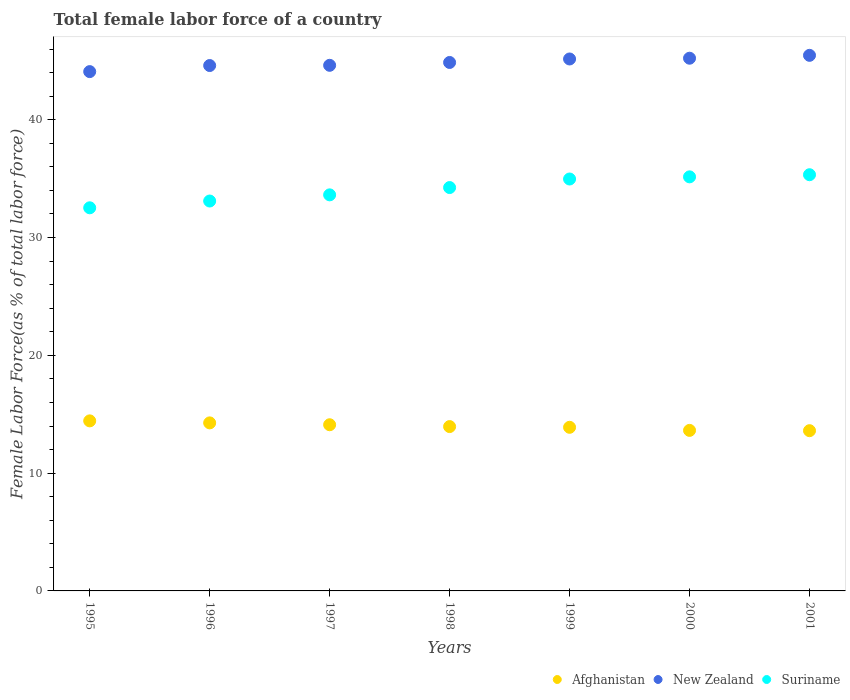How many different coloured dotlines are there?
Your answer should be compact. 3. Is the number of dotlines equal to the number of legend labels?
Your answer should be very brief. Yes. What is the percentage of female labor force in New Zealand in 1998?
Offer a very short reply. 44.86. Across all years, what is the maximum percentage of female labor force in Suriname?
Keep it short and to the point. 35.33. Across all years, what is the minimum percentage of female labor force in New Zealand?
Your answer should be very brief. 44.09. In which year was the percentage of female labor force in Suriname maximum?
Your response must be concise. 2001. What is the total percentage of female labor force in Afghanistan in the graph?
Provide a succinct answer. 97.88. What is the difference between the percentage of female labor force in Suriname in 1996 and that in 1999?
Make the answer very short. -1.87. What is the difference between the percentage of female labor force in Suriname in 1998 and the percentage of female labor force in New Zealand in 1999?
Your answer should be compact. -10.92. What is the average percentage of female labor force in Afghanistan per year?
Your answer should be very brief. 13.98. In the year 1997, what is the difference between the percentage of female labor force in New Zealand and percentage of female labor force in Afghanistan?
Offer a very short reply. 30.51. In how many years, is the percentage of female labor force in Afghanistan greater than 8 %?
Make the answer very short. 7. What is the ratio of the percentage of female labor force in New Zealand in 1995 to that in 2001?
Make the answer very short. 0.97. Is the percentage of female labor force in New Zealand in 1995 less than that in 1999?
Your answer should be very brief. Yes. What is the difference between the highest and the second highest percentage of female labor force in New Zealand?
Your response must be concise. 0.24. What is the difference between the highest and the lowest percentage of female labor force in New Zealand?
Offer a terse response. 1.38. Does the percentage of female labor force in Afghanistan monotonically increase over the years?
Offer a very short reply. No. Is the percentage of female labor force in Afghanistan strictly greater than the percentage of female labor force in New Zealand over the years?
Ensure brevity in your answer.  No. Is the percentage of female labor force in Afghanistan strictly less than the percentage of female labor force in New Zealand over the years?
Offer a terse response. Yes. What is the title of the graph?
Ensure brevity in your answer.  Total female labor force of a country. Does "Botswana" appear as one of the legend labels in the graph?
Provide a succinct answer. No. What is the label or title of the Y-axis?
Offer a very short reply. Female Labor Force(as % of total labor force). What is the Female Labor Force(as % of total labor force) in Afghanistan in 1995?
Provide a short and direct response. 14.44. What is the Female Labor Force(as % of total labor force) in New Zealand in 1995?
Offer a very short reply. 44.09. What is the Female Labor Force(as % of total labor force) of Suriname in 1995?
Your response must be concise. 32.53. What is the Female Labor Force(as % of total labor force) of Afghanistan in 1996?
Offer a terse response. 14.27. What is the Female Labor Force(as % of total labor force) of New Zealand in 1996?
Provide a short and direct response. 44.6. What is the Female Labor Force(as % of total labor force) in Suriname in 1996?
Provide a succinct answer. 33.1. What is the Female Labor Force(as % of total labor force) in Afghanistan in 1997?
Offer a very short reply. 14.11. What is the Female Labor Force(as % of total labor force) of New Zealand in 1997?
Keep it short and to the point. 44.62. What is the Female Labor Force(as % of total labor force) in Suriname in 1997?
Offer a terse response. 33.62. What is the Female Labor Force(as % of total labor force) of Afghanistan in 1998?
Provide a short and direct response. 13.95. What is the Female Labor Force(as % of total labor force) in New Zealand in 1998?
Your response must be concise. 44.86. What is the Female Labor Force(as % of total labor force) in Suriname in 1998?
Provide a short and direct response. 34.24. What is the Female Labor Force(as % of total labor force) of Afghanistan in 1999?
Give a very brief answer. 13.89. What is the Female Labor Force(as % of total labor force) of New Zealand in 1999?
Provide a succinct answer. 45.16. What is the Female Labor Force(as % of total labor force) of Suriname in 1999?
Your answer should be very brief. 34.97. What is the Female Labor Force(as % of total labor force) of Afghanistan in 2000?
Provide a succinct answer. 13.63. What is the Female Labor Force(as % of total labor force) in New Zealand in 2000?
Offer a terse response. 45.22. What is the Female Labor Force(as % of total labor force) of Suriname in 2000?
Ensure brevity in your answer.  35.15. What is the Female Labor Force(as % of total labor force) of Afghanistan in 2001?
Make the answer very short. 13.6. What is the Female Labor Force(as % of total labor force) in New Zealand in 2001?
Your response must be concise. 45.47. What is the Female Labor Force(as % of total labor force) of Suriname in 2001?
Make the answer very short. 35.33. Across all years, what is the maximum Female Labor Force(as % of total labor force) in Afghanistan?
Ensure brevity in your answer.  14.44. Across all years, what is the maximum Female Labor Force(as % of total labor force) of New Zealand?
Provide a short and direct response. 45.47. Across all years, what is the maximum Female Labor Force(as % of total labor force) in Suriname?
Provide a succinct answer. 35.33. Across all years, what is the minimum Female Labor Force(as % of total labor force) of Afghanistan?
Your answer should be very brief. 13.6. Across all years, what is the minimum Female Labor Force(as % of total labor force) of New Zealand?
Offer a terse response. 44.09. Across all years, what is the minimum Female Labor Force(as % of total labor force) in Suriname?
Keep it short and to the point. 32.53. What is the total Female Labor Force(as % of total labor force) in Afghanistan in the graph?
Provide a succinct answer. 97.88. What is the total Female Labor Force(as % of total labor force) in New Zealand in the graph?
Give a very brief answer. 314.02. What is the total Female Labor Force(as % of total labor force) of Suriname in the graph?
Provide a short and direct response. 238.95. What is the difference between the Female Labor Force(as % of total labor force) in Afghanistan in 1995 and that in 1996?
Make the answer very short. 0.17. What is the difference between the Female Labor Force(as % of total labor force) in New Zealand in 1995 and that in 1996?
Offer a very short reply. -0.52. What is the difference between the Female Labor Force(as % of total labor force) of Suriname in 1995 and that in 1996?
Your answer should be compact. -0.58. What is the difference between the Female Labor Force(as % of total labor force) in Afghanistan in 1995 and that in 1997?
Your answer should be very brief. 0.33. What is the difference between the Female Labor Force(as % of total labor force) of New Zealand in 1995 and that in 1997?
Your response must be concise. -0.53. What is the difference between the Female Labor Force(as % of total labor force) in Suriname in 1995 and that in 1997?
Provide a succinct answer. -1.1. What is the difference between the Female Labor Force(as % of total labor force) of Afghanistan in 1995 and that in 1998?
Offer a very short reply. 0.48. What is the difference between the Female Labor Force(as % of total labor force) of New Zealand in 1995 and that in 1998?
Offer a very short reply. -0.78. What is the difference between the Female Labor Force(as % of total labor force) in Suriname in 1995 and that in 1998?
Ensure brevity in your answer.  -1.72. What is the difference between the Female Labor Force(as % of total labor force) of Afghanistan in 1995 and that in 1999?
Your answer should be very brief. 0.55. What is the difference between the Female Labor Force(as % of total labor force) of New Zealand in 1995 and that in 1999?
Your answer should be very brief. -1.07. What is the difference between the Female Labor Force(as % of total labor force) in Suriname in 1995 and that in 1999?
Provide a succinct answer. -2.44. What is the difference between the Female Labor Force(as % of total labor force) of Afghanistan in 1995 and that in 2000?
Your answer should be very brief. 0.81. What is the difference between the Female Labor Force(as % of total labor force) of New Zealand in 1995 and that in 2000?
Your response must be concise. -1.14. What is the difference between the Female Labor Force(as % of total labor force) of Suriname in 1995 and that in 2000?
Provide a succinct answer. -2.63. What is the difference between the Female Labor Force(as % of total labor force) of Afghanistan in 1995 and that in 2001?
Offer a terse response. 0.83. What is the difference between the Female Labor Force(as % of total labor force) in New Zealand in 1995 and that in 2001?
Offer a very short reply. -1.38. What is the difference between the Female Labor Force(as % of total labor force) in Suriname in 1995 and that in 2001?
Offer a very short reply. -2.81. What is the difference between the Female Labor Force(as % of total labor force) of Afghanistan in 1996 and that in 1997?
Offer a terse response. 0.16. What is the difference between the Female Labor Force(as % of total labor force) in New Zealand in 1996 and that in 1997?
Provide a succinct answer. -0.02. What is the difference between the Female Labor Force(as % of total labor force) in Suriname in 1996 and that in 1997?
Give a very brief answer. -0.52. What is the difference between the Female Labor Force(as % of total labor force) of Afghanistan in 1996 and that in 1998?
Provide a short and direct response. 0.31. What is the difference between the Female Labor Force(as % of total labor force) of New Zealand in 1996 and that in 1998?
Your response must be concise. -0.26. What is the difference between the Female Labor Force(as % of total labor force) in Suriname in 1996 and that in 1998?
Your response must be concise. -1.14. What is the difference between the Female Labor Force(as % of total labor force) of Afghanistan in 1996 and that in 1999?
Provide a short and direct response. 0.38. What is the difference between the Female Labor Force(as % of total labor force) in New Zealand in 1996 and that in 1999?
Provide a short and direct response. -0.56. What is the difference between the Female Labor Force(as % of total labor force) of Suriname in 1996 and that in 1999?
Your answer should be compact. -1.87. What is the difference between the Female Labor Force(as % of total labor force) in Afghanistan in 1996 and that in 2000?
Provide a short and direct response. 0.64. What is the difference between the Female Labor Force(as % of total labor force) of New Zealand in 1996 and that in 2000?
Your answer should be compact. -0.62. What is the difference between the Female Labor Force(as % of total labor force) of Suriname in 1996 and that in 2000?
Keep it short and to the point. -2.05. What is the difference between the Female Labor Force(as % of total labor force) of Afghanistan in 1996 and that in 2001?
Give a very brief answer. 0.66. What is the difference between the Female Labor Force(as % of total labor force) in New Zealand in 1996 and that in 2001?
Your answer should be compact. -0.87. What is the difference between the Female Labor Force(as % of total labor force) in Suriname in 1996 and that in 2001?
Ensure brevity in your answer.  -2.23. What is the difference between the Female Labor Force(as % of total labor force) of Afghanistan in 1997 and that in 1998?
Offer a very short reply. 0.16. What is the difference between the Female Labor Force(as % of total labor force) of New Zealand in 1997 and that in 1998?
Offer a terse response. -0.24. What is the difference between the Female Labor Force(as % of total labor force) in Suriname in 1997 and that in 1998?
Your answer should be compact. -0.62. What is the difference between the Female Labor Force(as % of total labor force) in Afghanistan in 1997 and that in 1999?
Keep it short and to the point. 0.22. What is the difference between the Female Labor Force(as % of total labor force) in New Zealand in 1997 and that in 1999?
Ensure brevity in your answer.  -0.54. What is the difference between the Female Labor Force(as % of total labor force) in Suriname in 1997 and that in 1999?
Provide a succinct answer. -1.35. What is the difference between the Female Labor Force(as % of total labor force) in Afghanistan in 1997 and that in 2000?
Keep it short and to the point. 0.48. What is the difference between the Female Labor Force(as % of total labor force) in New Zealand in 1997 and that in 2000?
Offer a very short reply. -0.6. What is the difference between the Female Labor Force(as % of total labor force) in Suriname in 1997 and that in 2000?
Offer a very short reply. -1.53. What is the difference between the Female Labor Force(as % of total labor force) of Afghanistan in 1997 and that in 2001?
Keep it short and to the point. 0.51. What is the difference between the Female Labor Force(as % of total labor force) in New Zealand in 1997 and that in 2001?
Keep it short and to the point. -0.85. What is the difference between the Female Labor Force(as % of total labor force) of Suriname in 1997 and that in 2001?
Make the answer very short. -1.71. What is the difference between the Female Labor Force(as % of total labor force) in Afghanistan in 1998 and that in 1999?
Provide a short and direct response. 0.06. What is the difference between the Female Labor Force(as % of total labor force) in New Zealand in 1998 and that in 1999?
Make the answer very short. -0.3. What is the difference between the Female Labor Force(as % of total labor force) of Suriname in 1998 and that in 1999?
Provide a succinct answer. -0.73. What is the difference between the Female Labor Force(as % of total labor force) of Afghanistan in 1998 and that in 2000?
Offer a terse response. 0.32. What is the difference between the Female Labor Force(as % of total labor force) in New Zealand in 1998 and that in 2000?
Make the answer very short. -0.36. What is the difference between the Female Labor Force(as % of total labor force) in Suriname in 1998 and that in 2000?
Your answer should be very brief. -0.91. What is the difference between the Female Labor Force(as % of total labor force) in Afghanistan in 1998 and that in 2001?
Keep it short and to the point. 0.35. What is the difference between the Female Labor Force(as % of total labor force) in New Zealand in 1998 and that in 2001?
Offer a very short reply. -0.6. What is the difference between the Female Labor Force(as % of total labor force) of Suriname in 1998 and that in 2001?
Offer a terse response. -1.09. What is the difference between the Female Labor Force(as % of total labor force) of Afghanistan in 1999 and that in 2000?
Give a very brief answer. 0.26. What is the difference between the Female Labor Force(as % of total labor force) in New Zealand in 1999 and that in 2000?
Provide a short and direct response. -0.06. What is the difference between the Female Labor Force(as % of total labor force) of Suriname in 1999 and that in 2000?
Your response must be concise. -0.18. What is the difference between the Female Labor Force(as % of total labor force) in Afghanistan in 1999 and that in 2001?
Make the answer very short. 0.29. What is the difference between the Female Labor Force(as % of total labor force) in New Zealand in 1999 and that in 2001?
Offer a very short reply. -0.31. What is the difference between the Female Labor Force(as % of total labor force) in Suriname in 1999 and that in 2001?
Ensure brevity in your answer.  -0.36. What is the difference between the Female Labor Force(as % of total labor force) of Afghanistan in 2000 and that in 2001?
Your answer should be compact. 0.03. What is the difference between the Female Labor Force(as % of total labor force) in New Zealand in 2000 and that in 2001?
Your answer should be very brief. -0.24. What is the difference between the Female Labor Force(as % of total labor force) of Suriname in 2000 and that in 2001?
Make the answer very short. -0.18. What is the difference between the Female Labor Force(as % of total labor force) in Afghanistan in 1995 and the Female Labor Force(as % of total labor force) in New Zealand in 1996?
Make the answer very short. -30.17. What is the difference between the Female Labor Force(as % of total labor force) in Afghanistan in 1995 and the Female Labor Force(as % of total labor force) in Suriname in 1996?
Provide a short and direct response. -18.66. What is the difference between the Female Labor Force(as % of total labor force) in New Zealand in 1995 and the Female Labor Force(as % of total labor force) in Suriname in 1996?
Provide a succinct answer. 10.99. What is the difference between the Female Labor Force(as % of total labor force) in Afghanistan in 1995 and the Female Labor Force(as % of total labor force) in New Zealand in 1997?
Offer a very short reply. -30.18. What is the difference between the Female Labor Force(as % of total labor force) in Afghanistan in 1995 and the Female Labor Force(as % of total labor force) in Suriname in 1997?
Provide a succinct answer. -19.19. What is the difference between the Female Labor Force(as % of total labor force) in New Zealand in 1995 and the Female Labor Force(as % of total labor force) in Suriname in 1997?
Keep it short and to the point. 10.46. What is the difference between the Female Labor Force(as % of total labor force) of Afghanistan in 1995 and the Female Labor Force(as % of total labor force) of New Zealand in 1998?
Offer a terse response. -30.43. What is the difference between the Female Labor Force(as % of total labor force) in Afghanistan in 1995 and the Female Labor Force(as % of total labor force) in Suriname in 1998?
Keep it short and to the point. -19.81. What is the difference between the Female Labor Force(as % of total labor force) in New Zealand in 1995 and the Female Labor Force(as % of total labor force) in Suriname in 1998?
Your answer should be compact. 9.84. What is the difference between the Female Labor Force(as % of total labor force) in Afghanistan in 1995 and the Female Labor Force(as % of total labor force) in New Zealand in 1999?
Ensure brevity in your answer.  -30.72. What is the difference between the Female Labor Force(as % of total labor force) in Afghanistan in 1995 and the Female Labor Force(as % of total labor force) in Suriname in 1999?
Your answer should be very brief. -20.53. What is the difference between the Female Labor Force(as % of total labor force) in New Zealand in 1995 and the Female Labor Force(as % of total labor force) in Suriname in 1999?
Ensure brevity in your answer.  9.12. What is the difference between the Female Labor Force(as % of total labor force) of Afghanistan in 1995 and the Female Labor Force(as % of total labor force) of New Zealand in 2000?
Offer a very short reply. -30.79. What is the difference between the Female Labor Force(as % of total labor force) of Afghanistan in 1995 and the Female Labor Force(as % of total labor force) of Suriname in 2000?
Ensure brevity in your answer.  -20.72. What is the difference between the Female Labor Force(as % of total labor force) of New Zealand in 1995 and the Female Labor Force(as % of total labor force) of Suriname in 2000?
Give a very brief answer. 8.93. What is the difference between the Female Labor Force(as % of total labor force) in Afghanistan in 1995 and the Female Labor Force(as % of total labor force) in New Zealand in 2001?
Ensure brevity in your answer.  -31.03. What is the difference between the Female Labor Force(as % of total labor force) of Afghanistan in 1995 and the Female Labor Force(as % of total labor force) of Suriname in 2001?
Provide a short and direct response. -20.9. What is the difference between the Female Labor Force(as % of total labor force) of New Zealand in 1995 and the Female Labor Force(as % of total labor force) of Suriname in 2001?
Provide a short and direct response. 8.75. What is the difference between the Female Labor Force(as % of total labor force) in Afghanistan in 1996 and the Female Labor Force(as % of total labor force) in New Zealand in 1997?
Offer a terse response. -30.36. What is the difference between the Female Labor Force(as % of total labor force) of Afghanistan in 1996 and the Female Labor Force(as % of total labor force) of Suriname in 1997?
Give a very brief answer. -19.36. What is the difference between the Female Labor Force(as % of total labor force) in New Zealand in 1996 and the Female Labor Force(as % of total labor force) in Suriname in 1997?
Provide a succinct answer. 10.98. What is the difference between the Female Labor Force(as % of total labor force) of Afghanistan in 1996 and the Female Labor Force(as % of total labor force) of New Zealand in 1998?
Make the answer very short. -30.6. What is the difference between the Female Labor Force(as % of total labor force) of Afghanistan in 1996 and the Female Labor Force(as % of total labor force) of Suriname in 1998?
Keep it short and to the point. -19.98. What is the difference between the Female Labor Force(as % of total labor force) of New Zealand in 1996 and the Female Labor Force(as % of total labor force) of Suriname in 1998?
Provide a short and direct response. 10.36. What is the difference between the Female Labor Force(as % of total labor force) in Afghanistan in 1996 and the Female Labor Force(as % of total labor force) in New Zealand in 1999?
Keep it short and to the point. -30.89. What is the difference between the Female Labor Force(as % of total labor force) in Afghanistan in 1996 and the Female Labor Force(as % of total labor force) in Suriname in 1999?
Provide a short and direct response. -20.7. What is the difference between the Female Labor Force(as % of total labor force) in New Zealand in 1996 and the Female Labor Force(as % of total labor force) in Suriname in 1999?
Keep it short and to the point. 9.63. What is the difference between the Female Labor Force(as % of total labor force) in Afghanistan in 1996 and the Female Labor Force(as % of total labor force) in New Zealand in 2000?
Give a very brief answer. -30.96. What is the difference between the Female Labor Force(as % of total labor force) in Afghanistan in 1996 and the Female Labor Force(as % of total labor force) in Suriname in 2000?
Keep it short and to the point. -20.89. What is the difference between the Female Labor Force(as % of total labor force) of New Zealand in 1996 and the Female Labor Force(as % of total labor force) of Suriname in 2000?
Your response must be concise. 9.45. What is the difference between the Female Labor Force(as % of total labor force) of Afghanistan in 1996 and the Female Labor Force(as % of total labor force) of New Zealand in 2001?
Ensure brevity in your answer.  -31.2. What is the difference between the Female Labor Force(as % of total labor force) in Afghanistan in 1996 and the Female Labor Force(as % of total labor force) in Suriname in 2001?
Your answer should be compact. -21.07. What is the difference between the Female Labor Force(as % of total labor force) of New Zealand in 1996 and the Female Labor Force(as % of total labor force) of Suriname in 2001?
Your answer should be compact. 9.27. What is the difference between the Female Labor Force(as % of total labor force) in Afghanistan in 1997 and the Female Labor Force(as % of total labor force) in New Zealand in 1998?
Your answer should be very brief. -30.76. What is the difference between the Female Labor Force(as % of total labor force) of Afghanistan in 1997 and the Female Labor Force(as % of total labor force) of Suriname in 1998?
Provide a short and direct response. -20.14. What is the difference between the Female Labor Force(as % of total labor force) of New Zealand in 1997 and the Female Labor Force(as % of total labor force) of Suriname in 1998?
Offer a terse response. 10.38. What is the difference between the Female Labor Force(as % of total labor force) in Afghanistan in 1997 and the Female Labor Force(as % of total labor force) in New Zealand in 1999?
Ensure brevity in your answer.  -31.05. What is the difference between the Female Labor Force(as % of total labor force) in Afghanistan in 1997 and the Female Labor Force(as % of total labor force) in Suriname in 1999?
Offer a very short reply. -20.86. What is the difference between the Female Labor Force(as % of total labor force) in New Zealand in 1997 and the Female Labor Force(as % of total labor force) in Suriname in 1999?
Provide a succinct answer. 9.65. What is the difference between the Female Labor Force(as % of total labor force) in Afghanistan in 1997 and the Female Labor Force(as % of total labor force) in New Zealand in 2000?
Give a very brief answer. -31.12. What is the difference between the Female Labor Force(as % of total labor force) of Afghanistan in 1997 and the Female Labor Force(as % of total labor force) of Suriname in 2000?
Your answer should be compact. -21.04. What is the difference between the Female Labor Force(as % of total labor force) of New Zealand in 1997 and the Female Labor Force(as % of total labor force) of Suriname in 2000?
Give a very brief answer. 9.47. What is the difference between the Female Labor Force(as % of total labor force) in Afghanistan in 1997 and the Female Labor Force(as % of total labor force) in New Zealand in 2001?
Offer a terse response. -31.36. What is the difference between the Female Labor Force(as % of total labor force) of Afghanistan in 1997 and the Female Labor Force(as % of total labor force) of Suriname in 2001?
Your answer should be compact. -21.23. What is the difference between the Female Labor Force(as % of total labor force) in New Zealand in 1997 and the Female Labor Force(as % of total labor force) in Suriname in 2001?
Your response must be concise. 9.29. What is the difference between the Female Labor Force(as % of total labor force) in Afghanistan in 1998 and the Female Labor Force(as % of total labor force) in New Zealand in 1999?
Ensure brevity in your answer.  -31.21. What is the difference between the Female Labor Force(as % of total labor force) of Afghanistan in 1998 and the Female Labor Force(as % of total labor force) of Suriname in 1999?
Provide a succinct answer. -21.02. What is the difference between the Female Labor Force(as % of total labor force) in New Zealand in 1998 and the Female Labor Force(as % of total labor force) in Suriname in 1999?
Provide a short and direct response. 9.89. What is the difference between the Female Labor Force(as % of total labor force) in Afghanistan in 1998 and the Female Labor Force(as % of total labor force) in New Zealand in 2000?
Offer a terse response. -31.27. What is the difference between the Female Labor Force(as % of total labor force) of Afghanistan in 1998 and the Female Labor Force(as % of total labor force) of Suriname in 2000?
Give a very brief answer. -21.2. What is the difference between the Female Labor Force(as % of total labor force) of New Zealand in 1998 and the Female Labor Force(as % of total labor force) of Suriname in 2000?
Keep it short and to the point. 9.71. What is the difference between the Female Labor Force(as % of total labor force) in Afghanistan in 1998 and the Female Labor Force(as % of total labor force) in New Zealand in 2001?
Keep it short and to the point. -31.52. What is the difference between the Female Labor Force(as % of total labor force) in Afghanistan in 1998 and the Female Labor Force(as % of total labor force) in Suriname in 2001?
Offer a terse response. -21.38. What is the difference between the Female Labor Force(as % of total labor force) of New Zealand in 1998 and the Female Labor Force(as % of total labor force) of Suriname in 2001?
Ensure brevity in your answer.  9.53. What is the difference between the Female Labor Force(as % of total labor force) in Afghanistan in 1999 and the Female Labor Force(as % of total labor force) in New Zealand in 2000?
Your response must be concise. -31.33. What is the difference between the Female Labor Force(as % of total labor force) of Afghanistan in 1999 and the Female Labor Force(as % of total labor force) of Suriname in 2000?
Provide a short and direct response. -21.26. What is the difference between the Female Labor Force(as % of total labor force) of New Zealand in 1999 and the Female Labor Force(as % of total labor force) of Suriname in 2000?
Offer a terse response. 10.01. What is the difference between the Female Labor Force(as % of total labor force) of Afghanistan in 1999 and the Female Labor Force(as % of total labor force) of New Zealand in 2001?
Ensure brevity in your answer.  -31.58. What is the difference between the Female Labor Force(as % of total labor force) of Afghanistan in 1999 and the Female Labor Force(as % of total labor force) of Suriname in 2001?
Your answer should be compact. -21.44. What is the difference between the Female Labor Force(as % of total labor force) of New Zealand in 1999 and the Female Labor Force(as % of total labor force) of Suriname in 2001?
Give a very brief answer. 9.83. What is the difference between the Female Labor Force(as % of total labor force) in Afghanistan in 2000 and the Female Labor Force(as % of total labor force) in New Zealand in 2001?
Your answer should be very brief. -31.84. What is the difference between the Female Labor Force(as % of total labor force) in Afghanistan in 2000 and the Female Labor Force(as % of total labor force) in Suriname in 2001?
Ensure brevity in your answer.  -21.7. What is the difference between the Female Labor Force(as % of total labor force) of New Zealand in 2000 and the Female Labor Force(as % of total labor force) of Suriname in 2001?
Provide a short and direct response. 9.89. What is the average Female Labor Force(as % of total labor force) of Afghanistan per year?
Give a very brief answer. 13.98. What is the average Female Labor Force(as % of total labor force) in New Zealand per year?
Provide a succinct answer. 44.86. What is the average Female Labor Force(as % of total labor force) of Suriname per year?
Your response must be concise. 34.14. In the year 1995, what is the difference between the Female Labor Force(as % of total labor force) of Afghanistan and Female Labor Force(as % of total labor force) of New Zealand?
Keep it short and to the point. -29.65. In the year 1995, what is the difference between the Female Labor Force(as % of total labor force) in Afghanistan and Female Labor Force(as % of total labor force) in Suriname?
Provide a short and direct response. -18.09. In the year 1995, what is the difference between the Female Labor Force(as % of total labor force) of New Zealand and Female Labor Force(as % of total labor force) of Suriname?
Offer a very short reply. 11.56. In the year 1996, what is the difference between the Female Labor Force(as % of total labor force) of Afghanistan and Female Labor Force(as % of total labor force) of New Zealand?
Keep it short and to the point. -30.34. In the year 1996, what is the difference between the Female Labor Force(as % of total labor force) in Afghanistan and Female Labor Force(as % of total labor force) in Suriname?
Offer a terse response. -18.83. In the year 1996, what is the difference between the Female Labor Force(as % of total labor force) in New Zealand and Female Labor Force(as % of total labor force) in Suriname?
Your response must be concise. 11.5. In the year 1997, what is the difference between the Female Labor Force(as % of total labor force) of Afghanistan and Female Labor Force(as % of total labor force) of New Zealand?
Your answer should be compact. -30.51. In the year 1997, what is the difference between the Female Labor Force(as % of total labor force) of Afghanistan and Female Labor Force(as % of total labor force) of Suriname?
Keep it short and to the point. -19.52. In the year 1997, what is the difference between the Female Labor Force(as % of total labor force) of New Zealand and Female Labor Force(as % of total labor force) of Suriname?
Give a very brief answer. 11. In the year 1998, what is the difference between the Female Labor Force(as % of total labor force) in Afghanistan and Female Labor Force(as % of total labor force) in New Zealand?
Offer a terse response. -30.91. In the year 1998, what is the difference between the Female Labor Force(as % of total labor force) in Afghanistan and Female Labor Force(as % of total labor force) in Suriname?
Offer a terse response. -20.29. In the year 1998, what is the difference between the Female Labor Force(as % of total labor force) of New Zealand and Female Labor Force(as % of total labor force) of Suriname?
Make the answer very short. 10.62. In the year 1999, what is the difference between the Female Labor Force(as % of total labor force) in Afghanistan and Female Labor Force(as % of total labor force) in New Zealand?
Offer a terse response. -31.27. In the year 1999, what is the difference between the Female Labor Force(as % of total labor force) in Afghanistan and Female Labor Force(as % of total labor force) in Suriname?
Provide a short and direct response. -21.08. In the year 1999, what is the difference between the Female Labor Force(as % of total labor force) in New Zealand and Female Labor Force(as % of total labor force) in Suriname?
Provide a short and direct response. 10.19. In the year 2000, what is the difference between the Female Labor Force(as % of total labor force) of Afghanistan and Female Labor Force(as % of total labor force) of New Zealand?
Your response must be concise. -31.6. In the year 2000, what is the difference between the Female Labor Force(as % of total labor force) of Afghanistan and Female Labor Force(as % of total labor force) of Suriname?
Give a very brief answer. -21.52. In the year 2000, what is the difference between the Female Labor Force(as % of total labor force) of New Zealand and Female Labor Force(as % of total labor force) of Suriname?
Your answer should be very brief. 10.07. In the year 2001, what is the difference between the Female Labor Force(as % of total labor force) of Afghanistan and Female Labor Force(as % of total labor force) of New Zealand?
Your answer should be very brief. -31.87. In the year 2001, what is the difference between the Female Labor Force(as % of total labor force) in Afghanistan and Female Labor Force(as % of total labor force) in Suriname?
Your answer should be very brief. -21.73. In the year 2001, what is the difference between the Female Labor Force(as % of total labor force) in New Zealand and Female Labor Force(as % of total labor force) in Suriname?
Offer a terse response. 10.13. What is the ratio of the Female Labor Force(as % of total labor force) in Afghanistan in 1995 to that in 1996?
Your answer should be very brief. 1.01. What is the ratio of the Female Labor Force(as % of total labor force) in New Zealand in 1995 to that in 1996?
Provide a succinct answer. 0.99. What is the ratio of the Female Labor Force(as % of total labor force) of Suriname in 1995 to that in 1996?
Provide a short and direct response. 0.98. What is the ratio of the Female Labor Force(as % of total labor force) of Afghanistan in 1995 to that in 1997?
Make the answer very short. 1.02. What is the ratio of the Female Labor Force(as % of total labor force) of Suriname in 1995 to that in 1997?
Your response must be concise. 0.97. What is the ratio of the Female Labor Force(as % of total labor force) of Afghanistan in 1995 to that in 1998?
Offer a very short reply. 1.03. What is the ratio of the Female Labor Force(as % of total labor force) of New Zealand in 1995 to that in 1998?
Keep it short and to the point. 0.98. What is the ratio of the Female Labor Force(as % of total labor force) in Suriname in 1995 to that in 1998?
Provide a short and direct response. 0.95. What is the ratio of the Female Labor Force(as % of total labor force) of Afghanistan in 1995 to that in 1999?
Give a very brief answer. 1.04. What is the ratio of the Female Labor Force(as % of total labor force) in New Zealand in 1995 to that in 1999?
Offer a very short reply. 0.98. What is the ratio of the Female Labor Force(as % of total labor force) of Suriname in 1995 to that in 1999?
Provide a succinct answer. 0.93. What is the ratio of the Female Labor Force(as % of total labor force) of Afghanistan in 1995 to that in 2000?
Offer a very short reply. 1.06. What is the ratio of the Female Labor Force(as % of total labor force) of New Zealand in 1995 to that in 2000?
Your answer should be compact. 0.97. What is the ratio of the Female Labor Force(as % of total labor force) of Suriname in 1995 to that in 2000?
Provide a short and direct response. 0.93. What is the ratio of the Female Labor Force(as % of total labor force) in Afghanistan in 1995 to that in 2001?
Provide a short and direct response. 1.06. What is the ratio of the Female Labor Force(as % of total labor force) in New Zealand in 1995 to that in 2001?
Provide a succinct answer. 0.97. What is the ratio of the Female Labor Force(as % of total labor force) of Suriname in 1995 to that in 2001?
Your response must be concise. 0.92. What is the ratio of the Female Labor Force(as % of total labor force) in Afghanistan in 1996 to that in 1997?
Offer a terse response. 1.01. What is the ratio of the Female Labor Force(as % of total labor force) in New Zealand in 1996 to that in 1997?
Ensure brevity in your answer.  1. What is the ratio of the Female Labor Force(as % of total labor force) in Suriname in 1996 to that in 1997?
Ensure brevity in your answer.  0.98. What is the ratio of the Female Labor Force(as % of total labor force) of Afghanistan in 1996 to that in 1998?
Give a very brief answer. 1.02. What is the ratio of the Female Labor Force(as % of total labor force) of New Zealand in 1996 to that in 1998?
Make the answer very short. 0.99. What is the ratio of the Female Labor Force(as % of total labor force) of Suriname in 1996 to that in 1998?
Give a very brief answer. 0.97. What is the ratio of the Female Labor Force(as % of total labor force) in Afghanistan in 1996 to that in 1999?
Keep it short and to the point. 1.03. What is the ratio of the Female Labor Force(as % of total labor force) in New Zealand in 1996 to that in 1999?
Your answer should be very brief. 0.99. What is the ratio of the Female Labor Force(as % of total labor force) of Suriname in 1996 to that in 1999?
Ensure brevity in your answer.  0.95. What is the ratio of the Female Labor Force(as % of total labor force) in Afghanistan in 1996 to that in 2000?
Offer a very short reply. 1.05. What is the ratio of the Female Labor Force(as % of total labor force) of New Zealand in 1996 to that in 2000?
Provide a succinct answer. 0.99. What is the ratio of the Female Labor Force(as % of total labor force) of Suriname in 1996 to that in 2000?
Your answer should be very brief. 0.94. What is the ratio of the Female Labor Force(as % of total labor force) of Afghanistan in 1996 to that in 2001?
Offer a terse response. 1.05. What is the ratio of the Female Labor Force(as % of total labor force) of Suriname in 1996 to that in 2001?
Your answer should be very brief. 0.94. What is the ratio of the Female Labor Force(as % of total labor force) of Afghanistan in 1997 to that in 1998?
Provide a short and direct response. 1.01. What is the ratio of the Female Labor Force(as % of total labor force) of New Zealand in 1997 to that in 1998?
Make the answer very short. 0.99. What is the ratio of the Female Labor Force(as % of total labor force) in Suriname in 1997 to that in 1998?
Your answer should be compact. 0.98. What is the ratio of the Female Labor Force(as % of total labor force) of Afghanistan in 1997 to that in 1999?
Ensure brevity in your answer.  1.02. What is the ratio of the Female Labor Force(as % of total labor force) in New Zealand in 1997 to that in 1999?
Provide a succinct answer. 0.99. What is the ratio of the Female Labor Force(as % of total labor force) of Suriname in 1997 to that in 1999?
Make the answer very short. 0.96. What is the ratio of the Female Labor Force(as % of total labor force) of Afghanistan in 1997 to that in 2000?
Your answer should be compact. 1.04. What is the ratio of the Female Labor Force(as % of total labor force) of New Zealand in 1997 to that in 2000?
Offer a very short reply. 0.99. What is the ratio of the Female Labor Force(as % of total labor force) of Suriname in 1997 to that in 2000?
Your response must be concise. 0.96. What is the ratio of the Female Labor Force(as % of total labor force) of Afghanistan in 1997 to that in 2001?
Make the answer very short. 1.04. What is the ratio of the Female Labor Force(as % of total labor force) in New Zealand in 1997 to that in 2001?
Your answer should be compact. 0.98. What is the ratio of the Female Labor Force(as % of total labor force) in Suriname in 1997 to that in 2001?
Offer a very short reply. 0.95. What is the ratio of the Female Labor Force(as % of total labor force) in Afghanistan in 1998 to that in 1999?
Provide a succinct answer. 1. What is the ratio of the Female Labor Force(as % of total labor force) of New Zealand in 1998 to that in 1999?
Keep it short and to the point. 0.99. What is the ratio of the Female Labor Force(as % of total labor force) in Suriname in 1998 to that in 1999?
Your response must be concise. 0.98. What is the ratio of the Female Labor Force(as % of total labor force) in Afghanistan in 1998 to that in 2000?
Give a very brief answer. 1.02. What is the ratio of the Female Labor Force(as % of total labor force) of New Zealand in 1998 to that in 2000?
Your response must be concise. 0.99. What is the ratio of the Female Labor Force(as % of total labor force) in Suriname in 1998 to that in 2000?
Your answer should be very brief. 0.97. What is the ratio of the Female Labor Force(as % of total labor force) of Afghanistan in 1998 to that in 2001?
Offer a very short reply. 1.03. What is the ratio of the Female Labor Force(as % of total labor force) in New Zealand in 1998 to that in 2001?
Keep it short and to the point. 0.99. What is the ratio of the Female Labor Force(as % of total labor force) in Suriname in 1998 to that in 2001?
Provide a short and direct response. 0.97. What is the ratio of the Female Labor Force(as % of total labor force) in Afghanistan in 1999 to that in 2000?
Your answer should be compact. 1.02. What is the ratio of the Female Labor Force(as % of total labor force) in New Zealand in 1999 to that in 2000?
Ensure brevity in your answer.  1. What is the ratio of the Female Labor Force(as % of total labor force) of Afghanistan in 1999 to that in 2001?
Your answer should be compact. 1.02. What is the ratio of the Female Labor Force(as % of total labor force) in New Zealand in 1999 to that in 2001?
Make the answer very short. 0.99. What is the ratio of the Female Labor Force(as % of total labor force) of Suriname in 1999 to that in 2001?
Make the answer very short. 0.99. What is the ratio of the Female Labor Force(as % of total labor force) of Afghanistan in 2000 to that in 2001?
Your answer should be compact. 1. What is the ratio of the Female Labor Force(as % of total labor force) in Suriname in 2000 to that in 2001?
Give a very brief answer. 0.99. What is the difference between the highest and the second highest Female Labor Force(as % of total labor force) of Afghanistan?
Make the answer very short. 0.17. What is the difference between the highest and the second highest Female Labor Force(as % of total labor force) of New Zealand?
Keep it short and to the point. 0.24. What is the difference between the highest and the second highest Female Labor Force(as % of total labor force) of Suriname?
Offer a very short reply. 0.18. What is the difference between the highest and the lowest Female Labor Force(as % of total labor force) in Afghanistan?
Provide a short and direct response. 0.83. What is the difference between the highest and the lowest Female Labor Force(as % of total labor force) of New Zealand?
Offer a terse response. 1.38. What is the difference between the highest and the lowest Female Labor Force(as % of total labor force) in Suriname?
Provide a succinct answer. 2.81. 